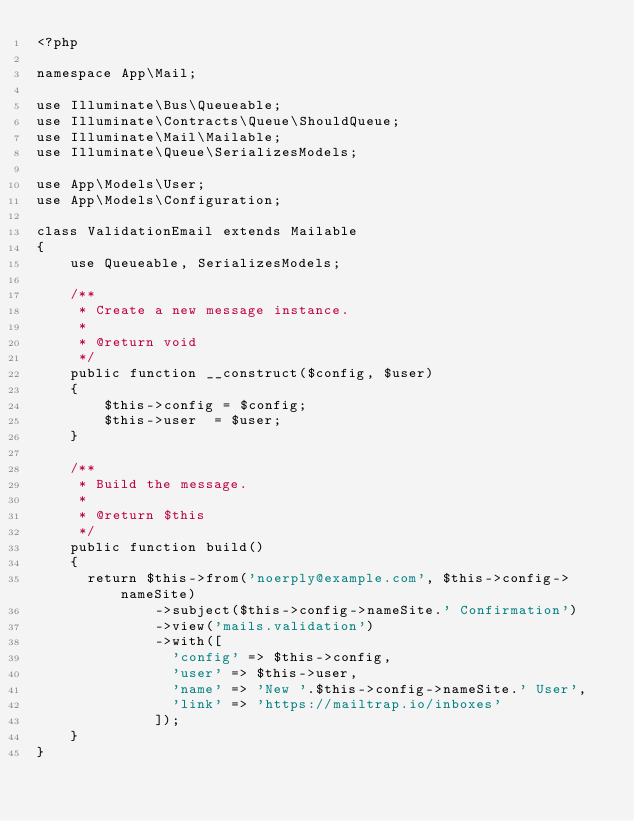<code> <loc_0><loc_0><loc_500><loc_500><_PHP_><?php

namespace App\Mail;

use Illuminate\Bus\Queueable;
use Illuminate\Contracts\Queue\ShouldQueue;
use Illuminate\Mail\Mailable;
use Illuminate\Queue\SerializesModels;

use App\Models\User;
use App\Models\Configuration;

class ValidationEmail extends Mailable
{
    use Queueable, SerializesModels;

    /**
     * Create a new message instance.
     *
     * @return void
     */
    public function __construct($config, $user)
    {
        $this->config = $config;
        $this->user  = $user;
    }

    /**
     * Build the message.
     *
     * @return $this
     */
    public function build()
    {
      return $this->from('noerply@example.com', $this->config->nameSite)
              ->subject($this->config->nameSite.' Confirmation')
              ->view('mails.validation')
              ->with([
                'config' => $this->config,
                'user' => $this->user,
                'name' => 'New '.$this->config->nameSite.' User',
                'link' => 'https://mailtrap.io/inboxes'
              ]);
    }
}
</code> 